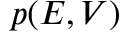Convert formula to latex. <formula><loc_0><loc_0><loc_500><loc_500>p ( E , V )</formula> 